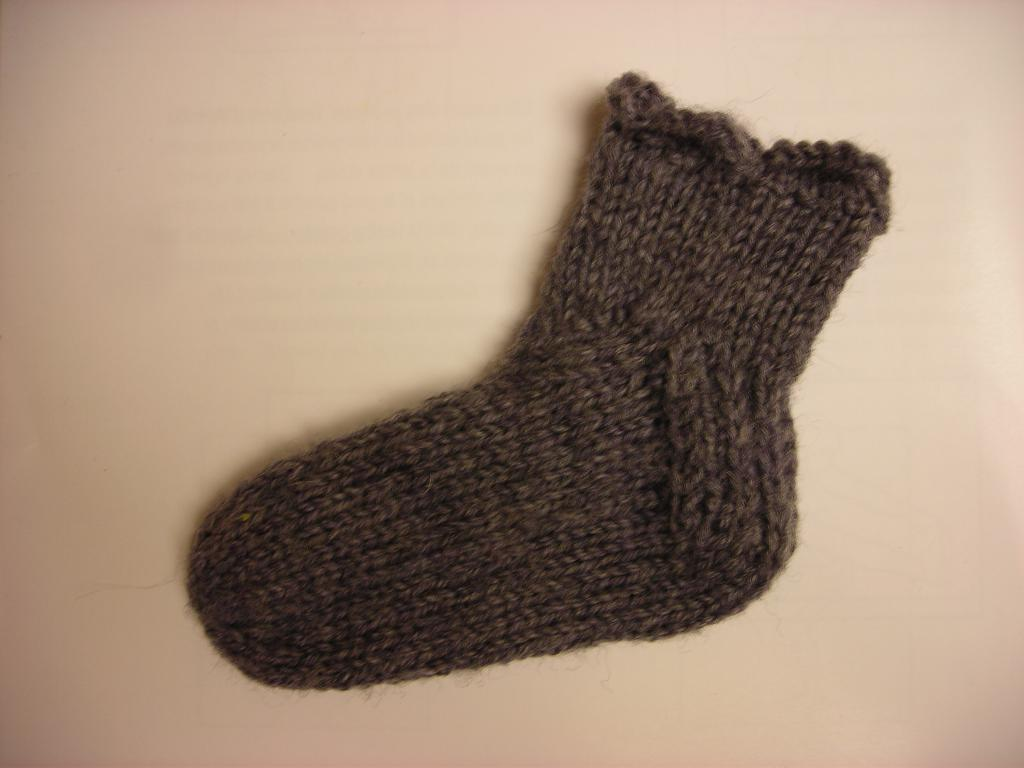What type of clothing item is in the image? There is a sock in the image. What color is the sock? The sock is brown in color. What color is the background of the image? The background of the image is cream colored. What type of rice can be seen in the image? There is no rice present in the image; it only features a brown sock against a cream-colored background. 